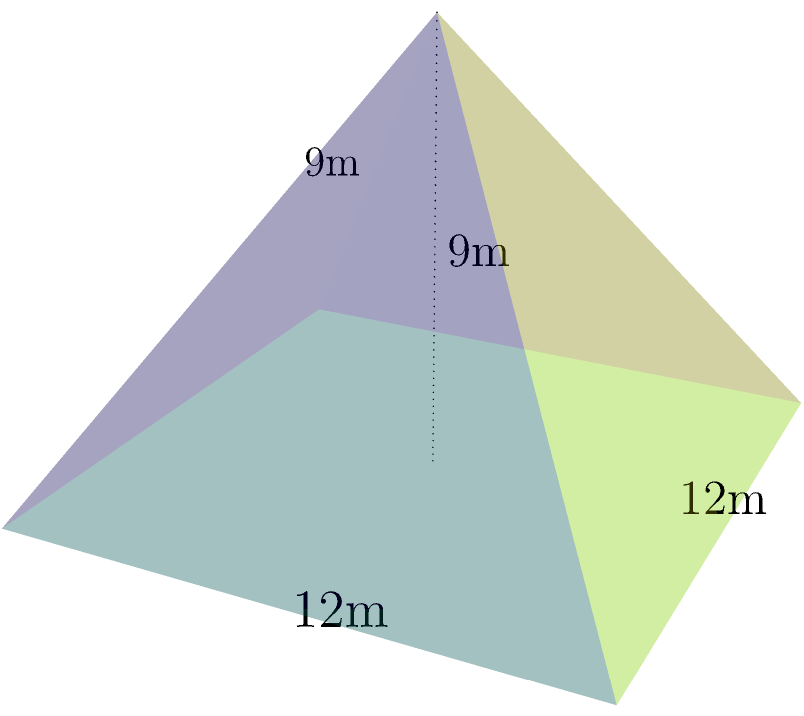A new international business center is being constructed in the shape of a pyramid with a square base. The building's base measures 12 meters on each side, and its height is 9 meters. As part of the construction team, you need to calculate the volume of this unique structure. What is the volume of this pyramid-shaped building in cubic meters? Let's approach this step-by-step:

1) The formula for the volume of a pyramid is:
   $$V = \frac{1}{3} \times B \times h$$
   where $V$ is the volume, $B$ is the area of the base, and $h$ is the height.

2) We know:
   - The base is a square with side length 12 meters
   - The height of the pyramid is 9 meters

3) First, let's calculate the area of the base:
   $$B = 12 \text{ m} \times 12 \text{ m} = 144 \text{ m}^2$$

4) Now we can plug our values into the volume formula:
   $$V = \frac{1}{3} \times 144 \text{ m}^2 \times 9 \text{ m}$$

5) Simplify:
   $$V = 48 \times 9 = 432 \text{ m}^3$$

Therefore, the volume of the pyramid-shaped building is 432 cubic meters.
Answer: 432 m³ 